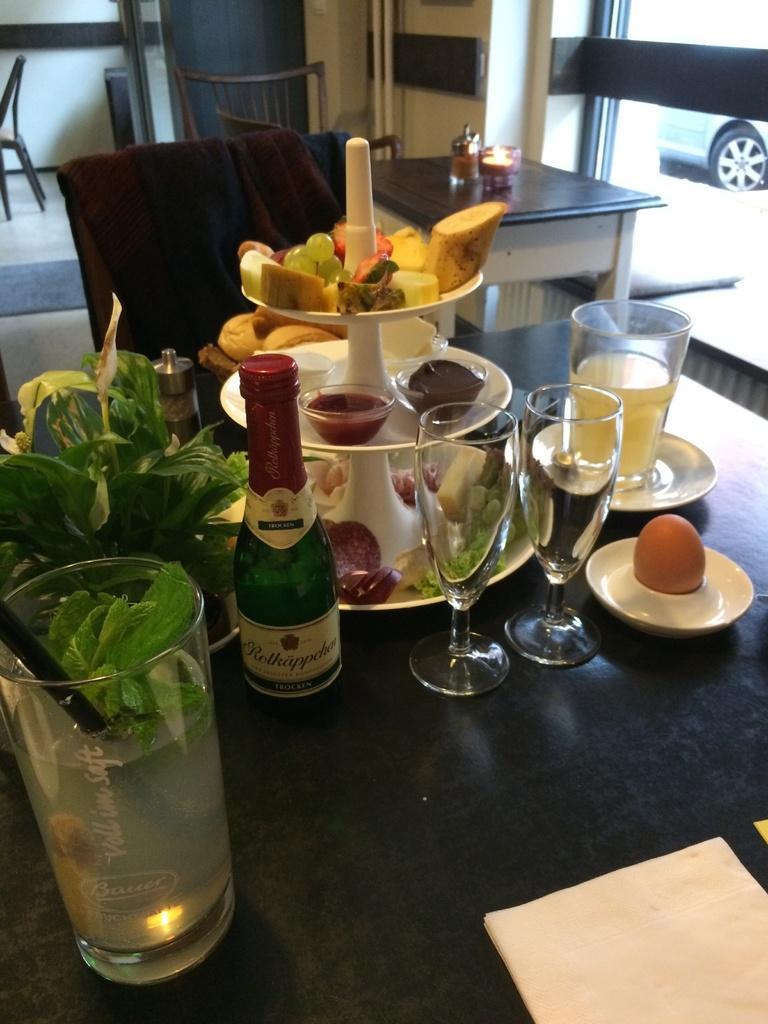How would you summarize this image in a sentence or two? In this picture we can see glasses, plant and some food items on the table, and we can see couple of chairs, in the background we can find a car. 